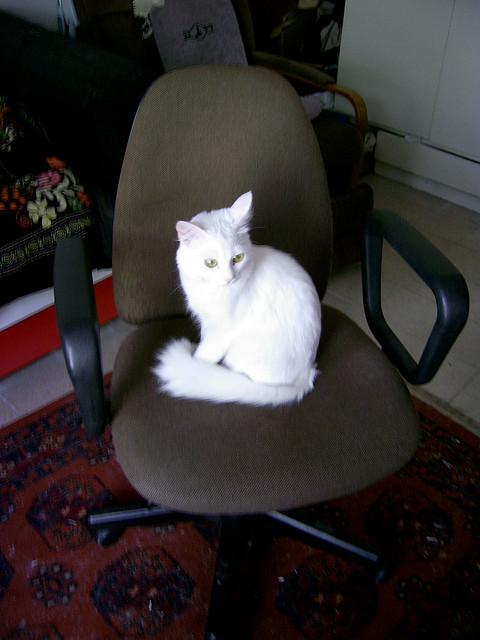Is the cat only one color?
Answer briefly. Yes. Is the cat seated?
Answer briefly. Yes. What color is this cat?
Write a very short answer. White. What material is the red chair made from?
Short answer required. No red chair. Where is the cat standing in the photograph?
Short answer required. Chair. What breed of cat is that?
Give a very brief answer. White. What color is the cat?
Keep it brief. White. Does the chair have any arms?
Write a very short answer. Yes. What is the cat looking at?
Be succinct. Floor. What does the cat wrap around itself?
Be succinct. Tail. 